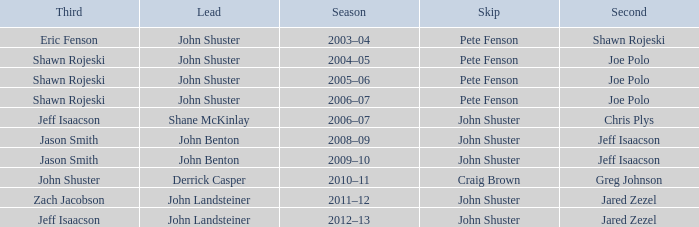Who was the lead with John Shuster as skip in the season of 2009–10? John Benton. 